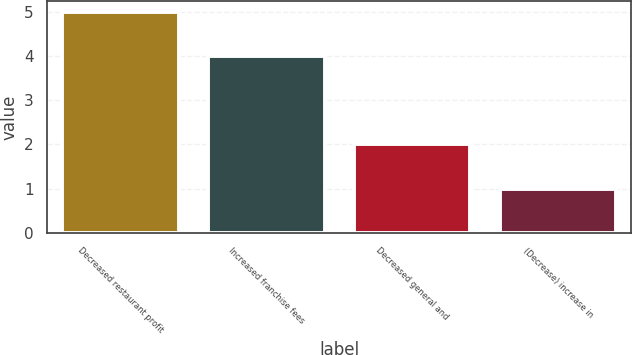Convert chart. <chart><loc_0><loc_0><loc_500><loc_500><bar_chart><fcel>Decreased restaurant profit<fcel>Increased franchise fees<fcel>Decreased general and<fcel>(Decrease) increase in<nl><fcel>5<fcel>4<fcel>2<fcel>1<nl></chart> 